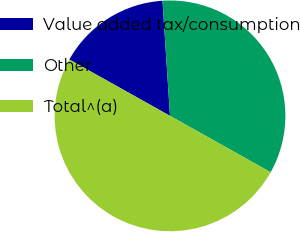Convert chart to OTSL. <chart><loc_0><loc_0><loc_500><loc_500><pie_chart><fcel>Value added tax/consumption<fcel>Other<fcel>Total^(a)<nl><fcel>15.84%<fcel>34.16%<fcel>50.0%<nl></chart> 